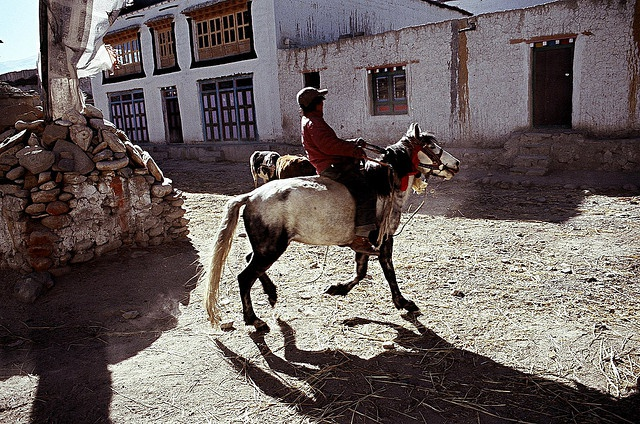Describe the objects in this image and their specific colors. I can see horse in lightblue, black, gray, and maroon tones, people in lightblue, black, maroon, gray, and darkgray tones, cow in lightblue, black, beige, tan, and darkgray tones, and cow in lightblue, black, white, gray, and darkgray tones in this image. 